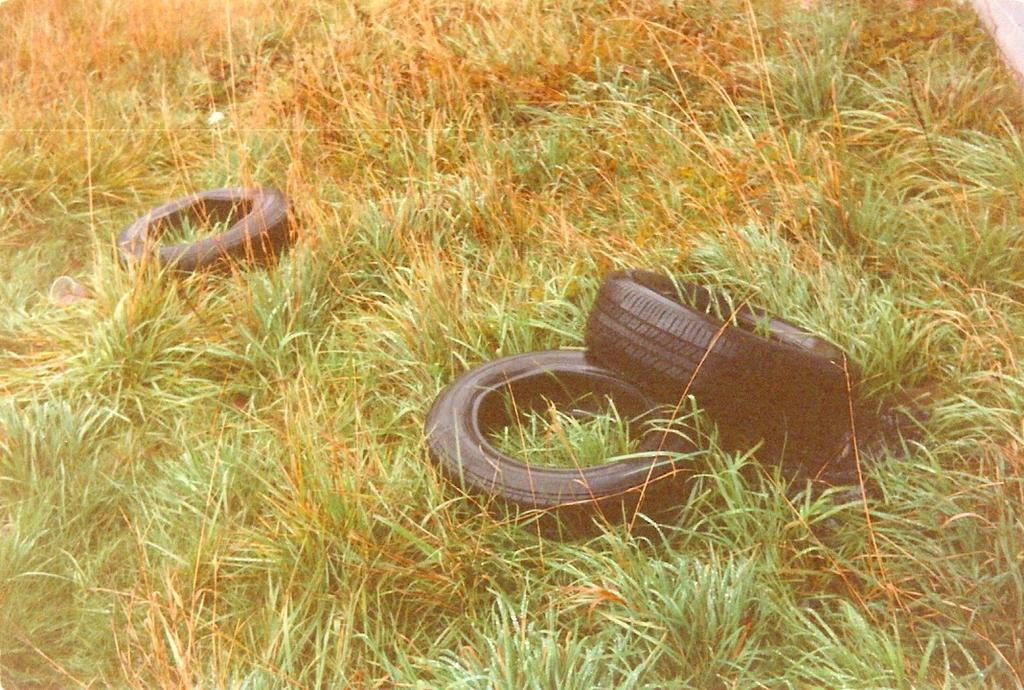What objects are present in the image? There are tires in the image. Where are the tires located? The tires are on the grass. What type of instrument is being played by the feet in the image? There are no feet or instruments present in the image; it only features tires on the grass. 